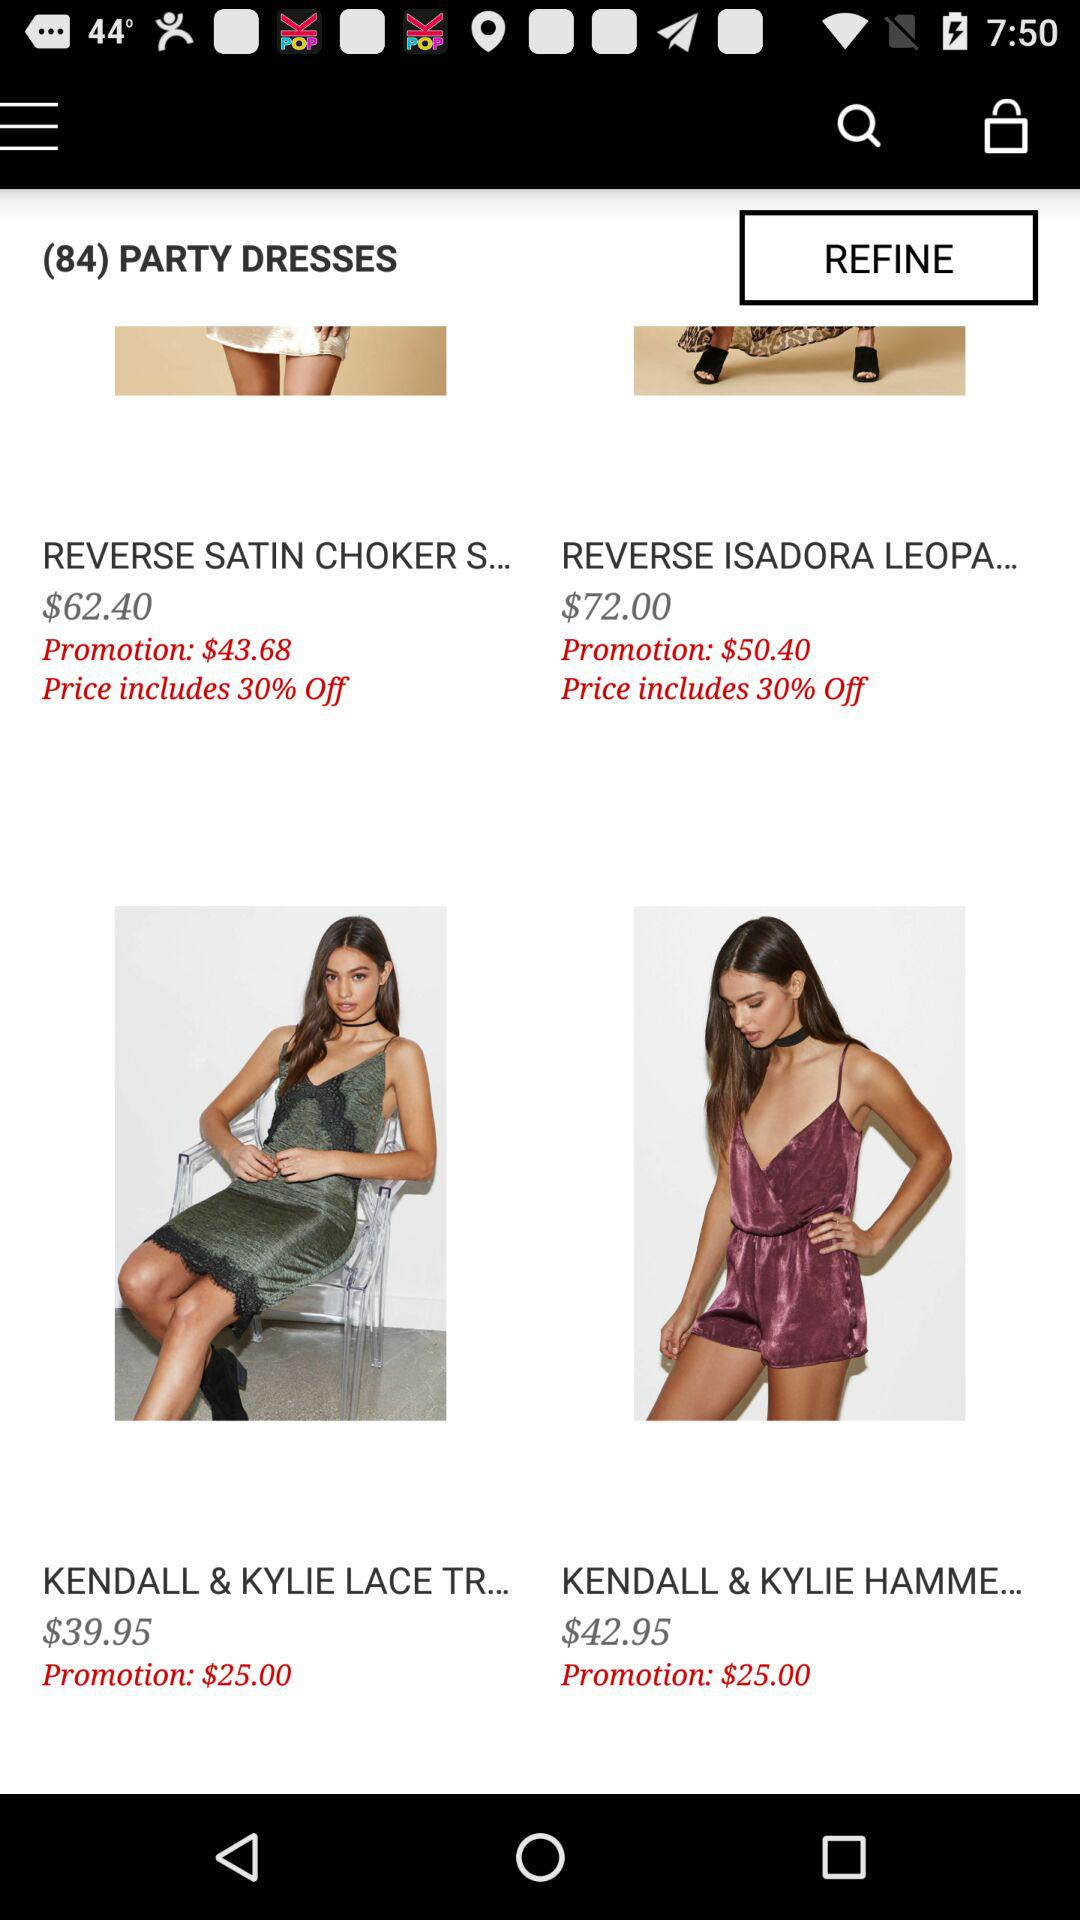What is the promotion price for "REVERSE SATIN CHOKER S..."? The promotion price is $43.68. 